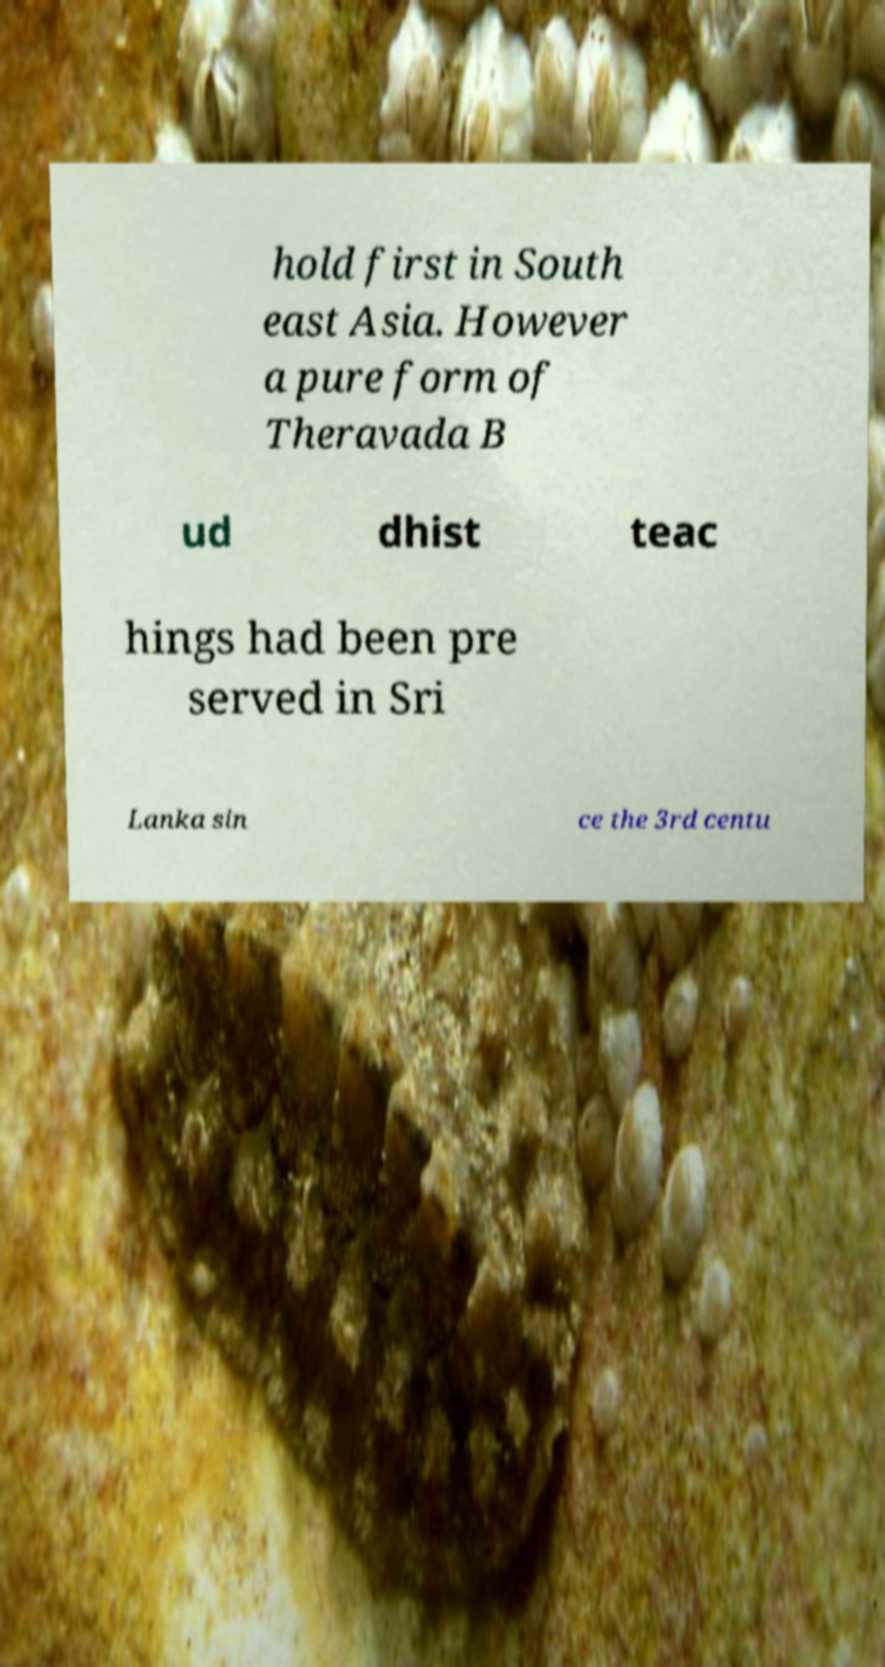Can you accurately transcribe the text from the provided image for me? hold first in South east Asia. However a pure form of Theravada B ud dhist teac hings had been pre served in Sri Lanka sin ce the 3rd centu 